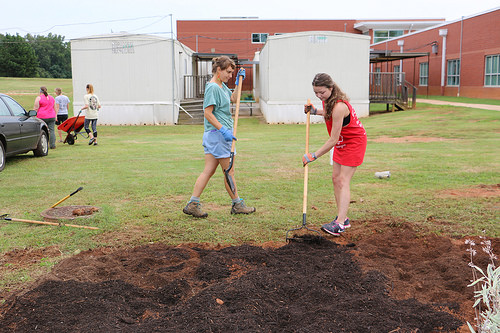<image>
Is the dirt under the person? No. The dirt is not positioned under the person. The vertical relationship between these objects is different. Is there a lady behind the car? Yes. From this viewpoint, the lady is positioned behind the car, with the car partially or fully occluding the lady. 